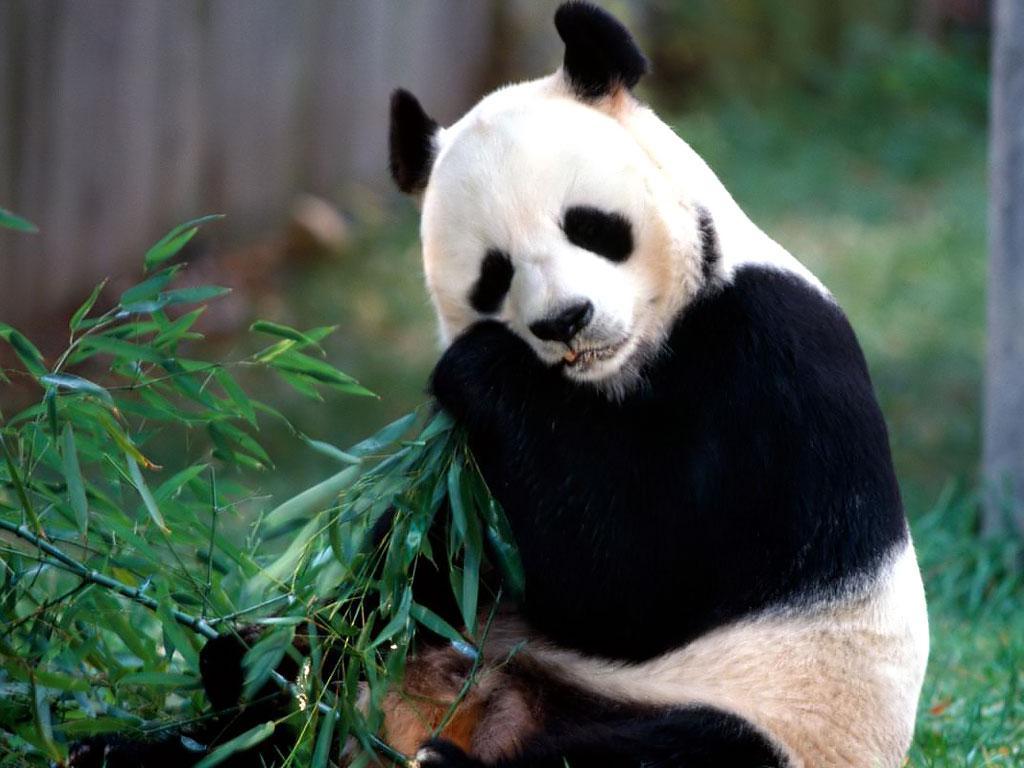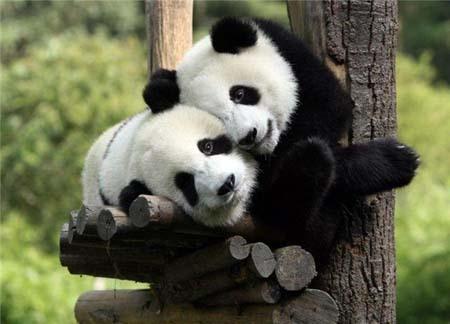The first image is the image on the left, the second image is the image on the right. For the images shown, is this caption "A shoot in the image on the left is in front of the panda's face." true? Answer yes or no. No. The first image is the image on the left, the second image is the image on the right. Given the left and right images, does the statement "Each image shows one forward-facing panda munching something, but the panda on the left is munching green leaves, while the panda on the right is munching yellow stalks." hold true? Answer yes or no. No. 